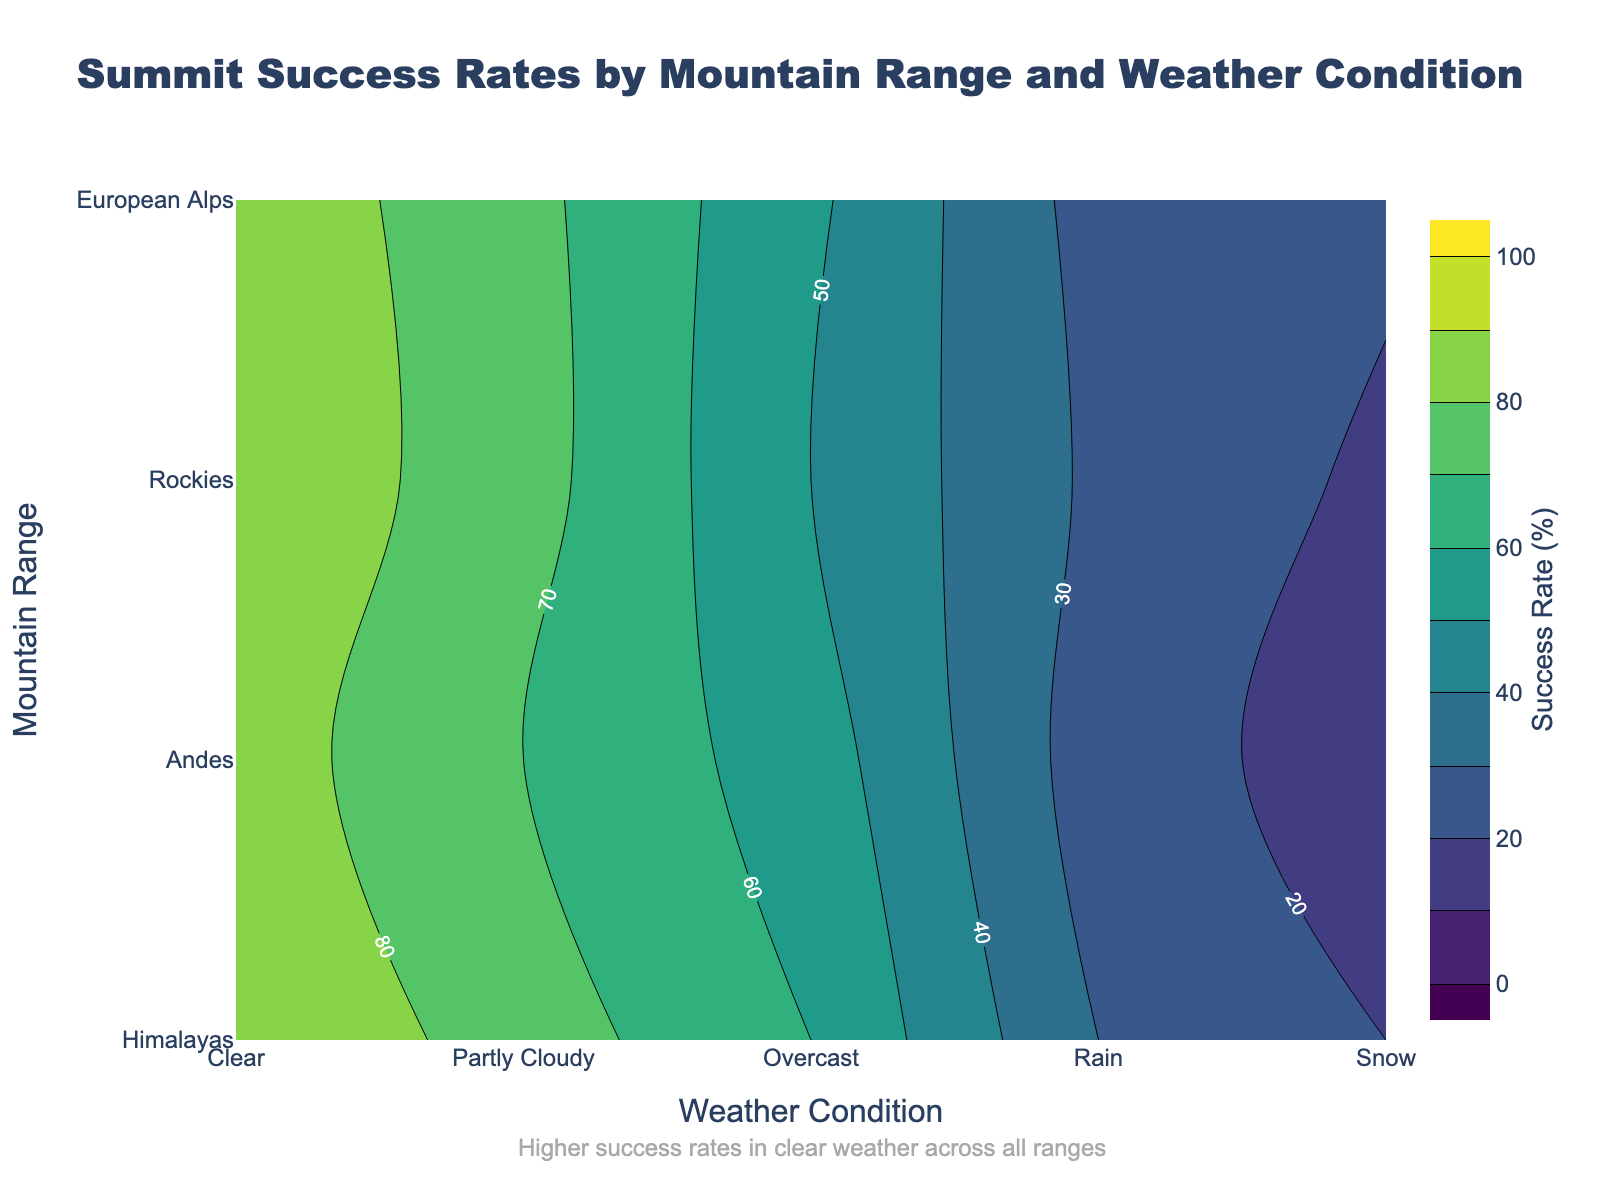What is the title of the plot? The title is located at the top center of the plot. It reads: "Summit Success Rates by Mountain Range and Weather Condition". This indicates the plot is about the success rates of summits across different mountain ranges under varying weather conditions.
Answer: Summit Success Rates by Mountain Range and Weather Condition Which mountain range has the highest success rate under clear weather conditions? In the contour plot, under the "Clear" weather condition on the x-axis, the Himalayas have the highest success rate contour level. The specific success rate is 90%, which is the peak value among all mountain ranges for this weather condition.
Answer: Himalayas How does the success rate change in the Andes from clear to snow conditions? To determine the change, we look at the corresponding success rates for the Andes on the y-axis: under "Clear" it's 85%, and under "Snow" it's 15%. The change can be calculated by subtracting the snow condition success rate from that of the clear condition. (85% - 15% = 70%)
Answer: 70% decrease Which weather condition exhibits the lowest success rate in the Rockies? By examining the contour lines and labels for the Rockies, the lowest success rate is found under "Snow" conditions. The contour label indicates a success rate of 18%.
Answer: Snow What do the color levels represent in the contour plot? The contour plot uses a color scale from the colorscale 'Viridis' to represent varying levels of summit success rates across different weather conditions and mountain ranges. Darker colors represent lower success rates, and lighter colors indicate higher success rates. The color bar on the right provides the exact mapping of colors to success rates between 0% and 100%.
Answer: Success Rates Compare the success rates of the Himalayas and the Andes for overcast weather conditions. Which is higher? By examining the contour labels under the "Overcast" condition, we see that the Himalayas have a success rate of 60% while the Andes have a success rate of 55%. Therefore, the Himalayas have a higher success rate for this weather condition.
Answer: Himalayas Is there any weather condition that shows a success rate above 80% regardless of the mountain range? By examining the contour plot for all weather conditions, only "Clear" weather consistently shows success rates above 80% across all mountain ranges. Other conditions like "Partly Cloudy" and worse have notably lower success rates.
Answer: Clear Identify the weather condition where success rates drop below 30% for all mountain ranges. By scanning the contour labels, "Snow" conditions show success rates below 30% for every mountain range. This condition shows significant challenge for summit attempts across the board.
Answer: Snow What does the annotation at the bottom of the plot indicate? The annotation text reads "Higher success rates in clear weather across all ranges" and is located at the bottom center of the plot. This emphasizes the visual insight that clear weather uniformly correlates with higher summit success rates across all the examined mountain ranges.
Answer: Higher success rates in clear weather across all ranges 